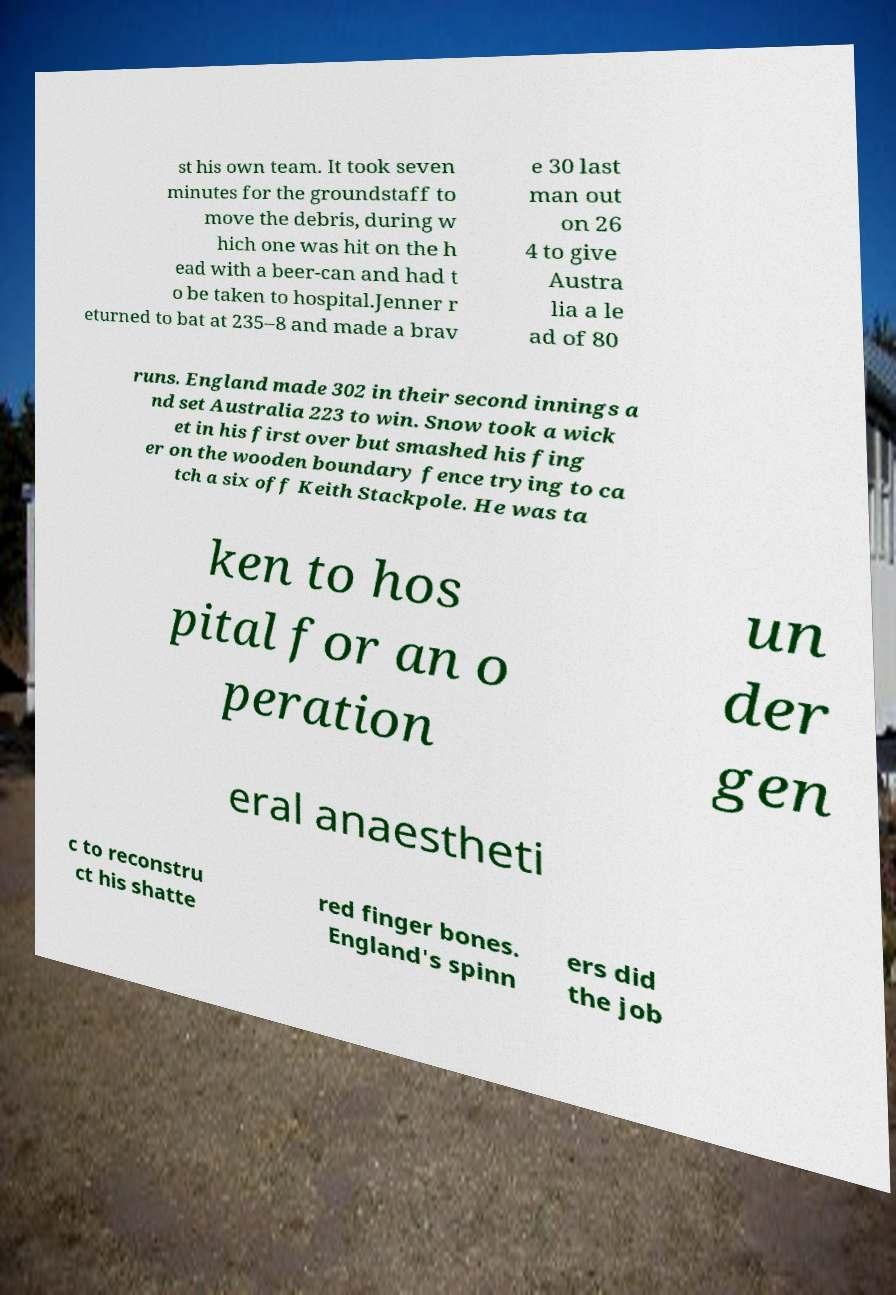There's text embedded in this image that I need extracted. Can you transcribe it verbatim? st his own team. It took seven minutes for the groundstaff to move the debris, during w hich one was hit on the h ead with a beer-can and had t o be taken to hospital.Jenner r eturned to bat at 235–8 and made a brav e 30 last man out on 26 4 to give Austra lia a le ad of 80 runs. England made 302 in their second innings a nd set Australia 223 to win. Snow took a wick et in his first over but smashed his fing er on the wooden boundary fence trying to ca tch a six off Keith Stackpole. He was ta ken to hos pital for an o peration un der gen eral anaestheti c to reconstru ct his shatte red finger bones. England's spinn ers did the job 